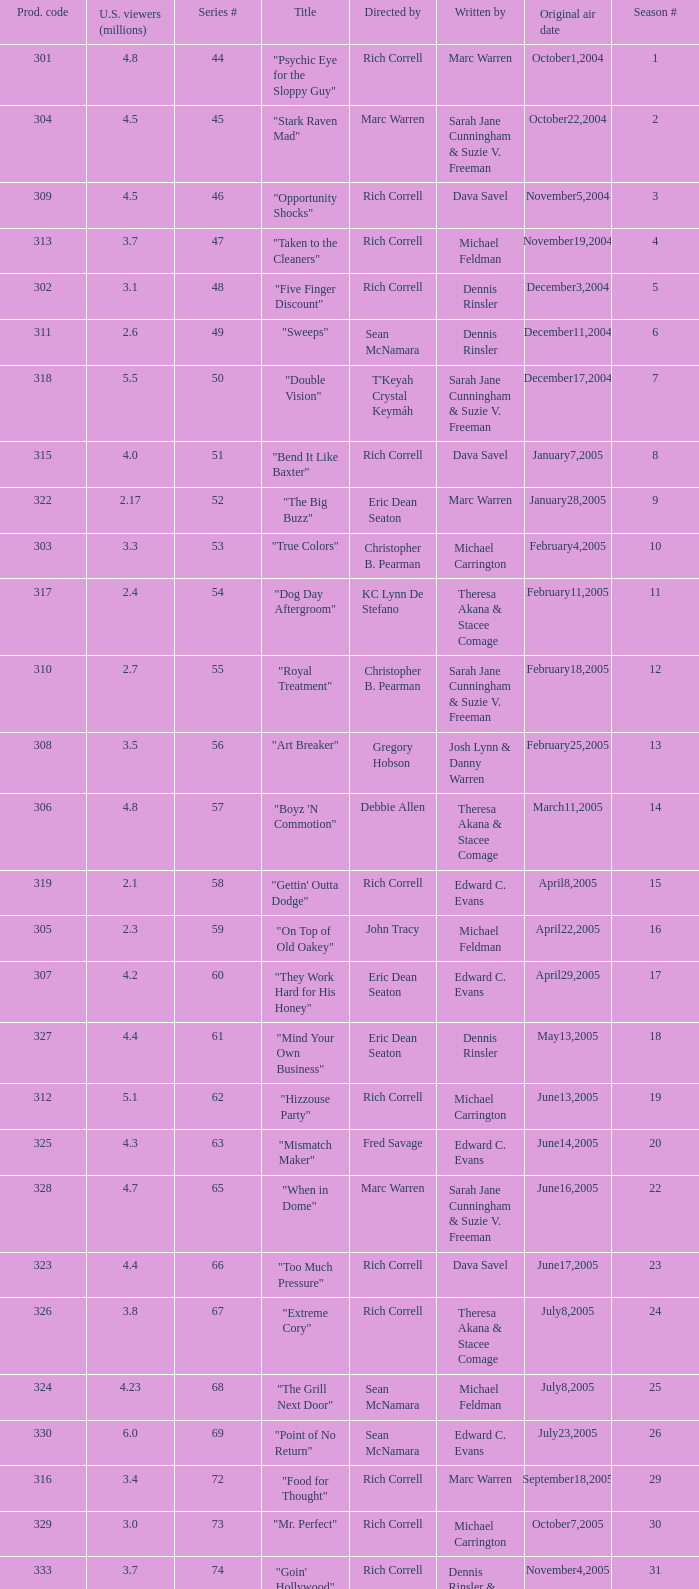What number episode of the season was titled "Vision Impossible"? 34.0. 